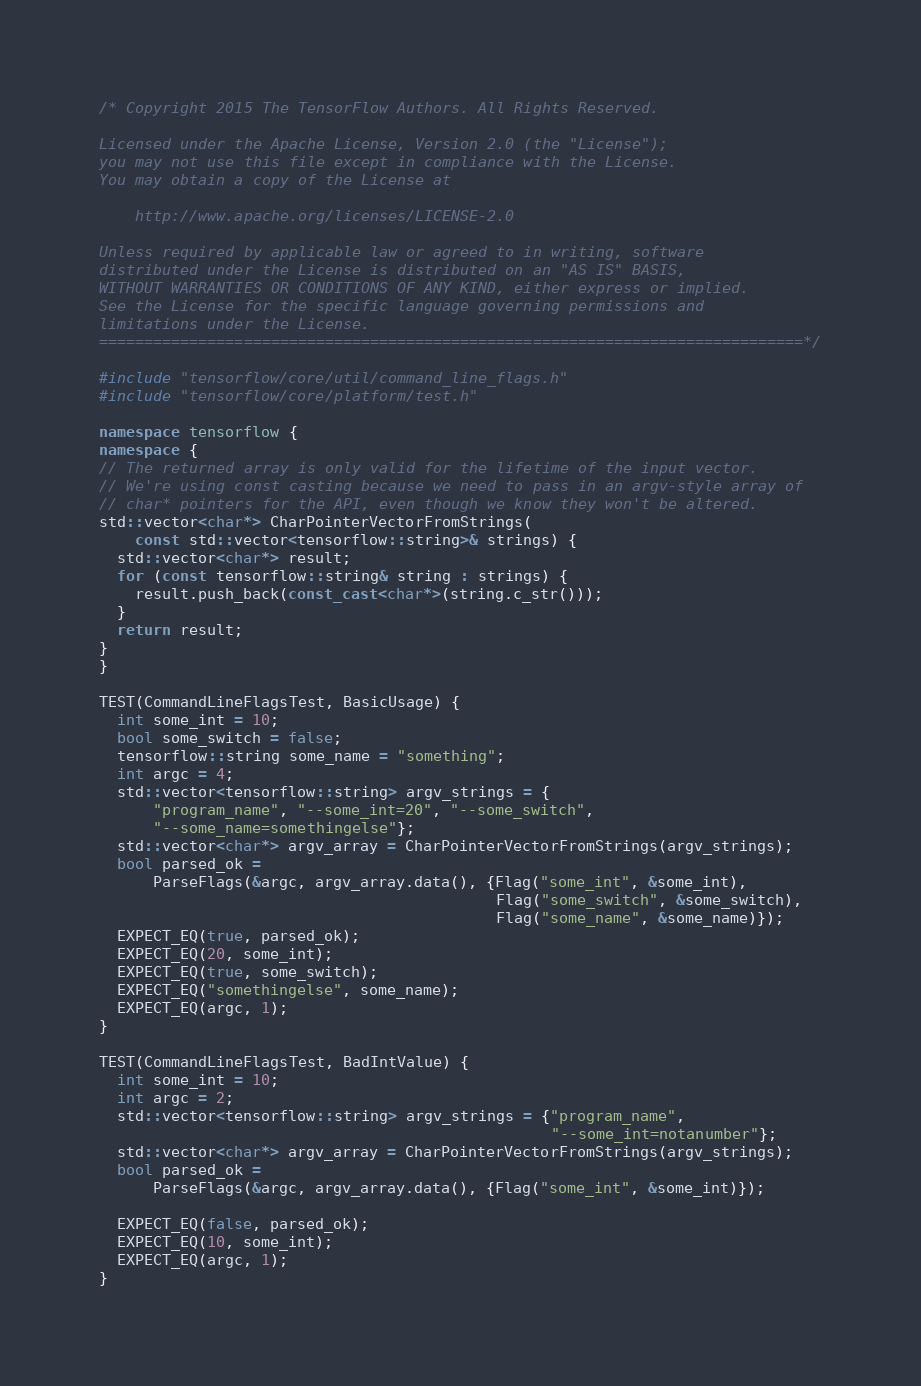Convert code to text. <code><loc_0><loc_0><loc_500><loc_500><_C++_>/* Copyright 2015 The TensorFlow Authors. All Rights Reserved.

Licensed under the Apache License, Version 2.0 (the "License");
you may not use this file except in compliance with the License.
You may obtain a copy of the License at

    http://www.apache.org/licenses/LICENSE-2.0

Unless required by applicable law or agreed to in writing, software
distributed under the License is distributed on an "AS IS" BASIS,
WITHOUT WARRANTIES OR CONDITIONS OF ANY KIND, either express or implied.
See the License for the specific language governing permissions and
limitations under the License.
==============================================================================*/

#include "tensorflow/core/util/command_line_flags.h"
#include "tensorflow/core/platform/test.h"

namespace tensorflow {
namespace {
// The returned array is only valid for the lifetime of the input vector.
// We're using const casting because we need to pass in an argv-style array of
// char* pointers for the API, even though we know they won't be altered.
std::vector<char*> CharPointerVectorFromStrings(
    const std::vector<tensorflow::string>& strings) {
  std::vector<char*> result;
  for (const tensorflow::string& string : strings) {
    result.push_back(const_cast<char*>(string.c_str()));
  }
  return result;
}
}

TEST(CommandLineFlagsTest, BasicUsage) {
  int some_int = 10;
  bool some_switch = false;
  tensorflow::string some_name = "something";
  int argc = 4;
  std::vector<tensorflow::string> argv_strings = {
      "program_name", "--some_int=20", "--some_switch",
      "--some_name=somethingelse"};
  std::vector<char*> argv_array = CharPointerVectorFromStrings(argv_strings);
  bool parsed_ok =
      ParseFlags(&argc, argv_array.data(), {Flag("some_int", &some_int),
                                            Flag("some_switch", &some_switch),
                                            Flag("some_name", &some_name)});
  EXPECT_EQ(true, parsed_ok);
  EXPECT_EQ(20, some_int);
  EXPECT_EQ(true, some_switch);
  EXPECT_EQ("somethingelse", some_name);
  EXPECT_EQ(argc, 1);
}

TEST(CommandLineFlagsTest, BadIntValue) {
  int some_int = 10;
  int argc = 2;
  std::vector<tensorflow::string> argv_strings = {"program_name",
                                                  "--some_int=notanumber"};
  std::vector<char*> argv_array = CharPointerVectorFromStrings(argv_strings);
  bool parsed_ok =
      ParseFlags(&argc, argv_array.data(), {Flag("some_int", &some_int)});

  EXPECT_EQ(false, parsed_ok);
  EXPECT_EQ(10, some_int);
  EXPECT_EQ(argc, 1);
}
</code> 